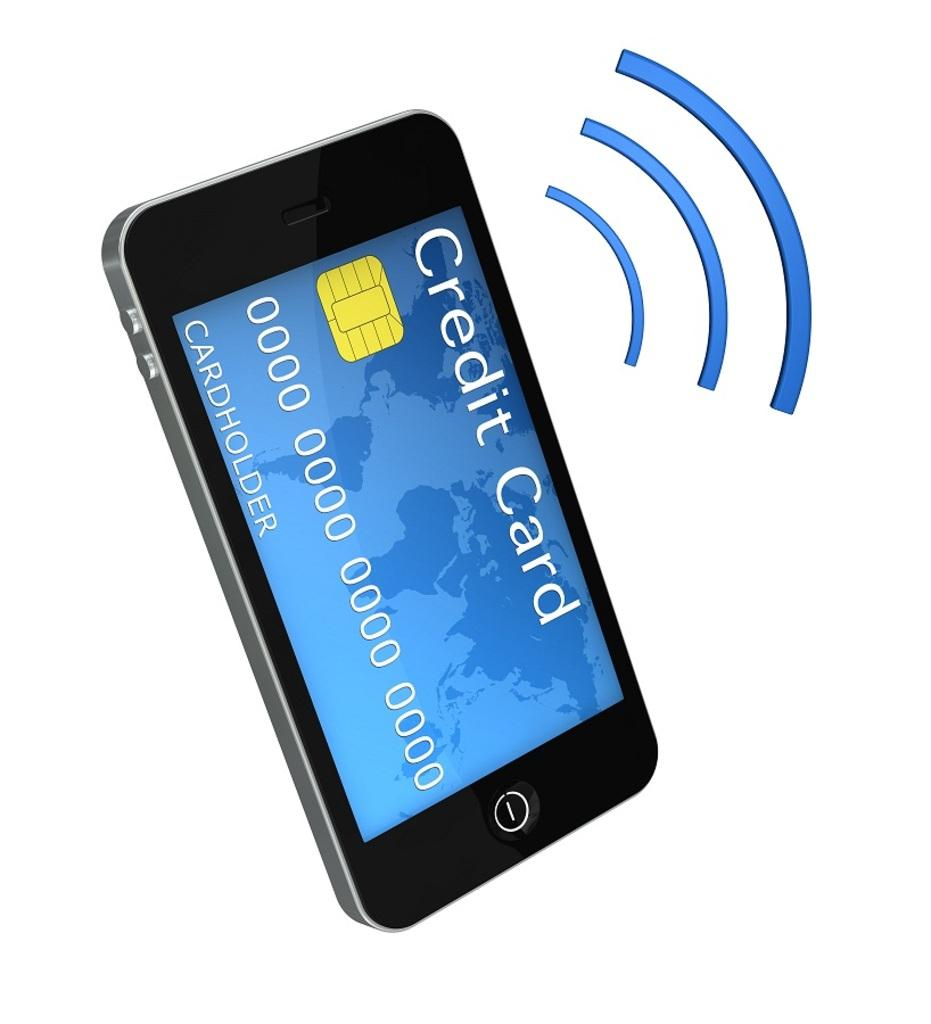<image>
Write a terse but informative summary of the picture. A phone that has a Credit Card on the screen and blue arced lines next to it. 